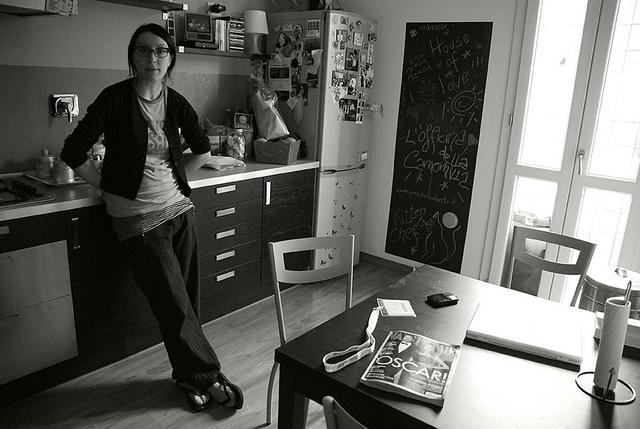Excellence in the American and International film industry award is what? Please explain your reasoning. oscar. You get an oscar if you win an award in the film industry. 